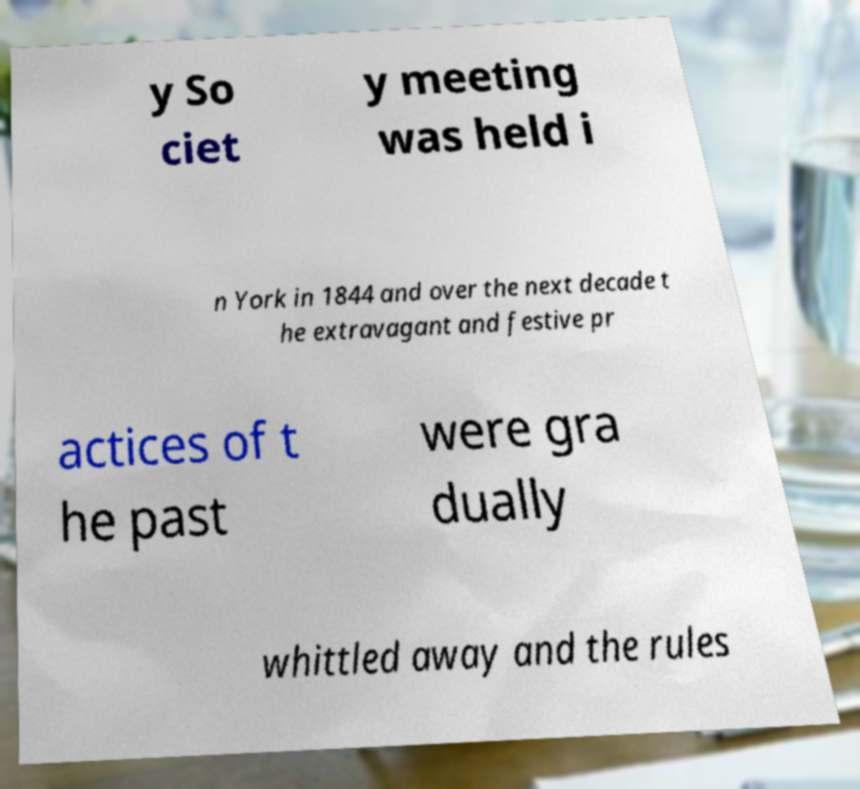Can you accurately transcribe the text from the provided image for me? y So ciet y meeting was held i n York in 1844 and over the next decade t he extravagant and festive pr actices of t he past were gra dually whittled away and the rules 